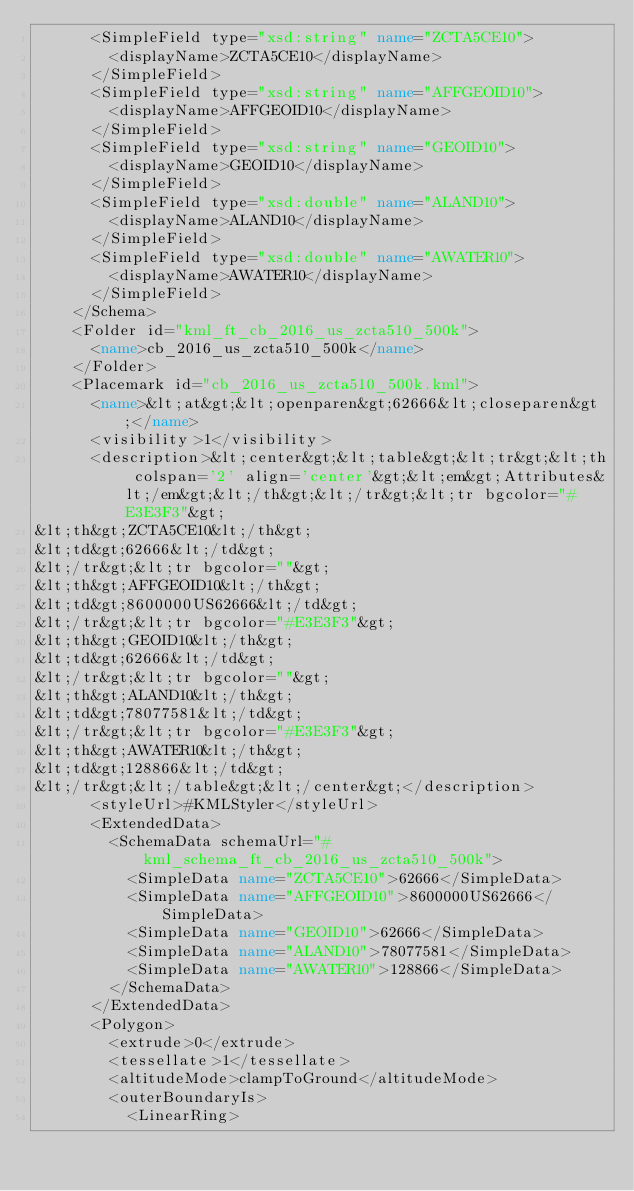<code> <loc_0><loc_0><loc_500><loc_500><_XML_>      <SimpleField type="xsd:string" name="ZCTA5CE10">
        <displayName>ZCTA5CE10</displayName>
      </SimpleField>
      <SimpleField type="xsd:string" name="AFFGEOID10">
        <displayName>AFFGEOID10</displayName>
      </SimpleField>
      <SimpleField type="xsd:string" name="GEOID10">
        <displayName>GEOID10</displayName>
      </SimpleField>
      <SimpleField type="xsd:double" name="ALAND10">
        <displayName>ALAND10</displayName>
      </SimpleField>
      <SimpleField type="xsd:double" name="AWATER10">
        <displayName>AWATER10</displayName>
      </SimpleField>
    </Schema>
    <Folder id="kml_ft_cb_2016_us_zcta510_500k">
      <name>cb_2016_us_zcta510_500k</name>
    </Folder>
    <Placemark id="cb_2016_us_zcta510_500k.kml">
      <name>&lt;at&gt;&lt;openparen&gt;62666&lt;closeparen&gt;</name>
      <visibility>1</visibility>
      <description>&lt;center&gt;&lt;table&gt;&lt;tr&gt;&lt;th colspan='2' align='center'&gt;&lt;em&gt;Attributes&lt;/em&gt;&lt;/th&gt;&lt;/tr&gt;&lt;tr bgcolor="#E3E3F3"&gt;
&lt;th&gt;ZCTA5CE10&lt;/th&gt;
&lt;td&gt;62666&lt;/td&gt;
&lt;/tr&gt;&lt;tr bgcolor=""&gt;
&lt;th&gt;AFFGEOID10&lt;/th&gt;
&lt;td&gt;8600000US62666&lt;/td&gt;
&lt;/tr&gt;&lt;tr bgcolor="#E3E3F3"&gt;
&lt;th&gt;GEOID10&lt;/th&gt;
&lt;td&gt;62666&lt;/td&gt;
&lt;/tr&gt;&lt;tr bgcolor=""&gt;
&lt;th&gt;ALAND10&lt;/th&gt;
&lt;td&gt;78077581&lt;/td&gt;
&lt;/tr&gt;&lt;tr bgcolor="#E3E3F3"&gt;
&lt;th&gt;AWATER10&lt;/th&gt;
&lt;td&gt;128866&lt;/td&gt;
&lt;/tr&gt;&lt;/table&gt;&lt;/center&gt;</description>
      <styleUrl>#KMLStyler</styleUrl>
      <ExtendedData>
        <SchemaData schemaUrl="#kml_schema_ft_cb_2016_us_zcta510_500k">
          <SimpleData name="ZCTA5CE10">62666</SimpleData>
          <SimpleData name="AFFGEOID10">8600000US62666</SimpleData>
          <SimpleData name="GEOID10">62666</SimpleData>
          <SimpleData name="ALAND10">78077581</SimpleData>
          <SimpleData name="AWATER10">128866</SimpleData>
        </SchemaData>
      </ExtendedData>
      <Polygon>
        <extrude>0</extrude>
        <tessellate>1</tessellate>
        <altitudeMode>clampToGround</altitudeMode>
        <outerBoundaryIs>
          <LinearRing></code> 